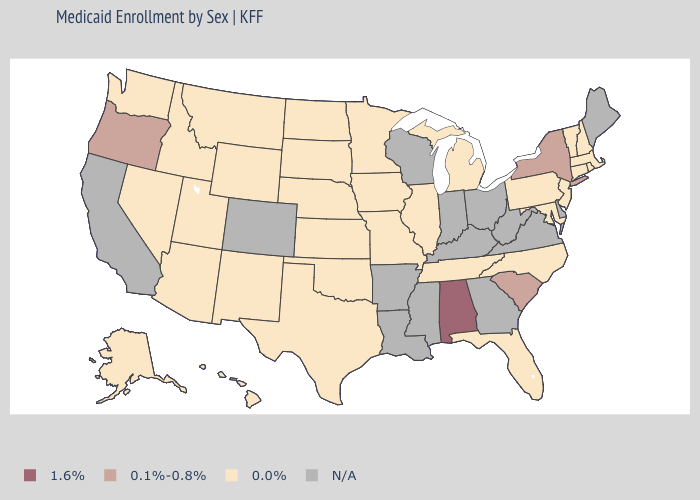Does the first symbol in the legend represent the smallest category?
Give a very brief answer. No. What is the lowest value in the West?
Short answer required. 0.0%. Among the states that border Idaho , does Montana have the lowest value?
Give a very brief answer. Yes. What is the value of Delaware?
Quick response, please. N/A. What is the value of Wyoming?
Concise answer only. 0.0%. Name the states that have a value in the range 0.0%?
Be succinct. Alaska, Arizona, Connecticut, Florida, Hawaii, Idaho, Illinois, Iowa, Kansas, Maryland, Massachusetts, Michigan, Minnesota, Missouri, Montana, Nebraska, Nevada, New Hampshire, New Jersey, New Mexico, North Carolina, North Dakota, Oklahoma, Pennsylvania, Rhode Island, South Dakota, Tennessee, Texas, Utah, Vermont, Washington, Wyoming. Among the states that border Nebraska , which have the highest value?
Quick response, please. Iowa, Kansas, Missouri, South Dakota, Wyoming. Name the states that have a value in the range 0.1%-0.8%?
Be succinct. New York, Oregon, South Carolina. What is the value of Louisiana?
Quick response, please. N/A. Name the states that have a value in the range 0.0%?
Write a very short answer. Alaska, Arizona, Connecticut, Florida, Hawaii, Idaho, Illinois, Iowa, Kansas, Maryland, Massachusetts, Michigan, Minnesota, Missouri, Montana, Nebraska, Nevada, New Hampshire, New Jersey, New Mexico, North Carolina, North Dakota, Oklahoma, Pennsylvania, Rhode Island, South Dakota, Tennessee, Texas, Utah, Vermont, Washington, Wyoming. Name the states that have a value in the range 0.1%-0.8%?
Quick response, please. New York, Oregon, South Carolina. What is the lowest value in the USA?
Keep it brief. 0.0%. What is the highest value in the West ?
Give a very brief answer. 0.1%-0.8%. What is the value of Massachusetts?
Write a very short answer. 0.0%. 